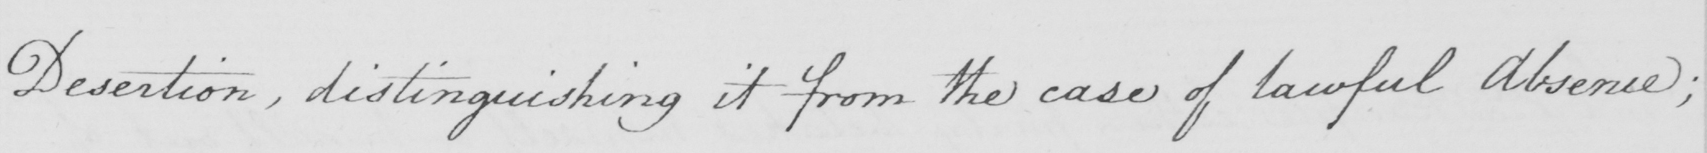Please transcribe the handwritten text in this image. Desertion, distinguishing it from the case of lawful Absence; 